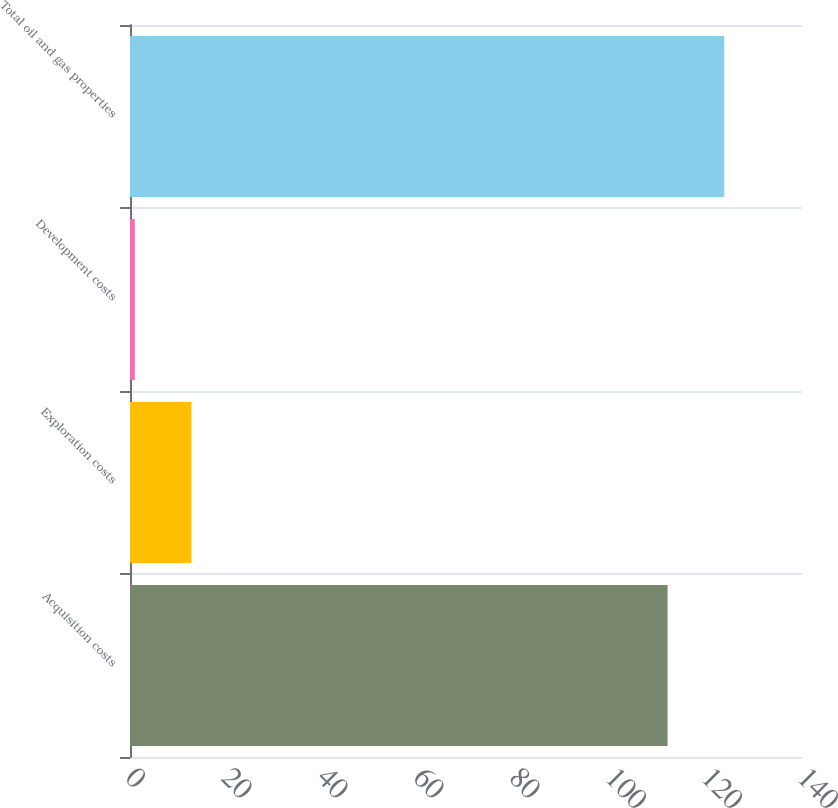<chart> <loc_0><loc_0><loc_500><loc_500><bar_chart><fcel>Acquisition costs<fcel>Exploration costs<fcel>Development costs<fcel>Total oil and gas properties<nl><fcel>112<fcel>12.8<fcel>1<fcel>123.8<nl></chart> 